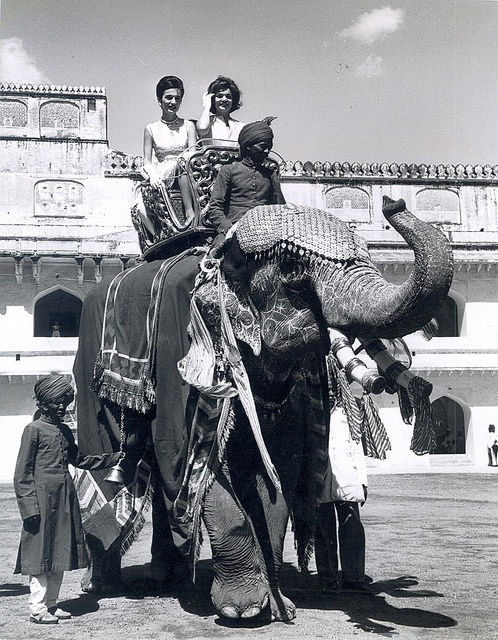Describe the objects in this image and their specific colors. I can see elephant in lightgray, black, gray, and darkgray tones, people in lightgray, gray, black, and darkgray tones, people in lightgray, black, white, gray, and darkgray tones, people in lightgray, gray, and black tones, and people in lightgray, white, darkgray, gray, and black tones in this image. 